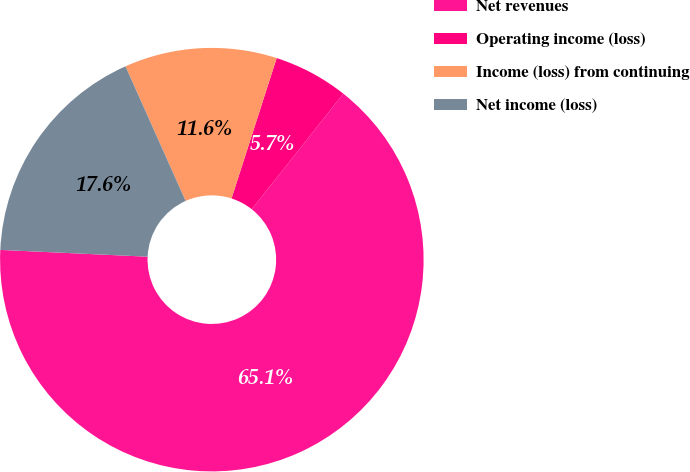Convert chart to OTSL. <chart><loc_0><loc_0><loc_500><loc_500><pie_chart><fcel>Net revenues<fcel>Operating income (loss)<fcel>Income (loss) from continuing<fcel>Net income (loss)<nl><fcel>65.07%<fcel>5.71%<fcel>11.64%<fcel>17.58%<nl></chart> 